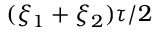Convert formula to latex. <formula><loc_0><loc_0><loc_500><loc_500>( \xi _ { 1 } + \xi _ { 2 } ) \tau / 2</formula> 